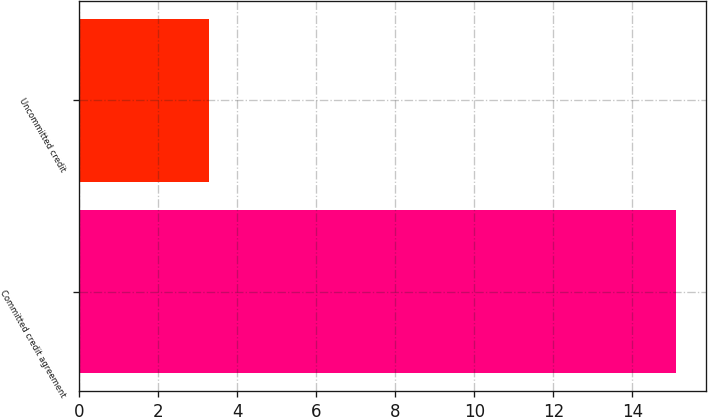Convert chart. <chart><loc_0><loc_0><loc_500><loc_500><bar_chart><fcel>Committed credit agreement<fcel>Uncommitted credit<nl><fcel>15.1<fcel>3.3<nl></chart> 